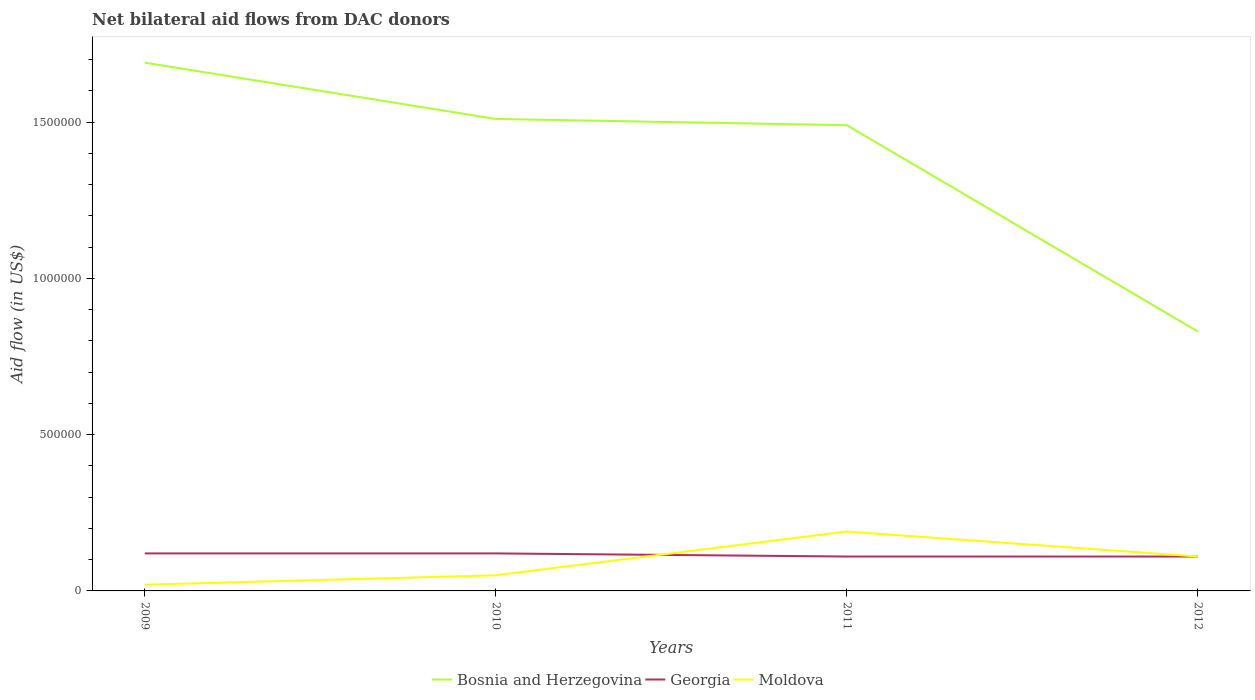How many different coloured lines are there?
Your answer should be very brief. 3. Across all years, what is the maximum net bilateral aid flow in Georgia?
Keep it short and to the point. 1.10e+05. What is the total net bilateral aid flow in Bosnia and Herzegovina in the graph?
Your response must be concise. 6.80e+05. Is the net bilateral aid flow in Bosnia and Herzegovina strictly greater than the net bilateral aid flow in Georgia over the years?
Your answer should be compact. No. What is the difference between two consecutive major ticks on the Y-axis?
Your response must be concise. 5.00e+05. Are the values on the major ticks of Y-axis written in scientific E-notation?
Your answer should be very brief. No. Does the graph contain any zero values?
Provide a succinct answer. No. Does the graph contain grids?
Your response must be concise. No. Where does the legend appear in the graph?
Your answer should be very brief. Bottom center. How many legend labels are there?
Ensure brevity in your answer.  3. What is the title of the graph?
Your answer should be compact. Net bilateral aid flows from DAC donors. Does "Equatorial Guinea" appear as one of the legend labels in the graph?
Provide a short and direct response. No. What is the label or title of the X-axis?
Your answer should be very brief. Years. What is the label or title of the Y-axis?
Your answer should be very brief. Aid flow (in US$). What is the Aid flow (in US$) of Bosnia and Herzegovina in 2009?
Offer a terse response. 1.69e+06. What is the Aid flow (in US$) of Moldova in 2009?
Your response must be concise. 2.00e+04. What is the Aid flow (in US$) of Bosnia and Herzegovina in 2010?
Your response must be concise. 1.51e+06. What is the Aid flow (in US$) in Moldova in 2010?
Provide a short and direct response. 5.00e+04. What is the Aid flow (in US$) in Bosnia and Herzegovina in 2011?
Your response must be concise. 1.49e+06. What is the Aid flow (in US$) in Georgia in 2011?
Make the answer very short. 1.10e+05. What is the Aid flow (in US$) in Bosnia and Herzegovina in 2012?
Keep it short and to the point. 8.30e+05. What is the Aid flow (in US$) in Georgia in 2012?
Ensure brevity in your answer.  1.10e+05. What is the Aid flow (in US$) in Moldova in 2012?
Your response must be concise. 1.10e+05. Across all years, what is the maximum Aid flow (in US$) in Bosnia and Herzegovina?
Offer a terse response. 1.69e+06. Across all years, what is the maximum Aid flow (in US$) in Moldova?
Your response must be concise. 1.90e+05. Across all years, what is the minimum Aid flow (in US$) of Bosnia and Herzegovina?
Keep it short and to the point. 8.30e+05. Across all years, what is the minimum Aid flow (in US$) of Moldova?
Make the answer very short. 2.00e+04. What is the total Aid flow (in US$) in Bosnia and Herzegovina in the graph?
Provide a succinct answer. 5.52e+06. What is the total Aid flow (in US$) of Georgia in the graph?
Provide a succinct answer. 4.60e+05. What is the total Aid flow (in US$) of Moldova in the graph?
Provide a succinct answer. 3.70e+05. What is the difference between the Aid flow (in US$) of Bosnia and Herzegovina in 2009 and that in 2010?
Your response must be concise. 1.80e+05. What is the difference between the Aid flow (in US$) in Georgia in 2009 and that in 2010?
Provide a succinct answer. 0. What is the difference between the Aid flow (in US$) in Moldova in 2009 and that in 2010?
Your answer should be very brief. -3.00e+04. What is the difference between the Aid flow (in US$) in Georgia in 2009 and that in 2011?
Your answer should be compact. 10000. What is the difference between the Aid flow (in US$) in Bosnia and Herzegovina in 2009 and that in 2012?
Your answer should be very brief. 8.60e+05. What is the difference between the Aid flow (in US$) of Bosnia and Herzegovina in 2010 and that in 2011?
Ensure brevity in your answer.  2.00e+04. What is the difference between the Aid flow (in US$) in Moldova in 2010 and that in 2011?
Offer a terse response. -1.40e+05. What is the difference between the Aid flow (in US$) of Bosnia and Herzegovina in 2010 and that in 2012?
Ensure brevity in your answer.  6.80e+05. What is the difference between the Aid flow (in US$) of Georgia in 2010 and that in 2012?
Provide a short and direct response. 10000. What is the difference between the Aid flow (in US$) in Moldova in 2010 and that in 2012?
Your answer should be compact. -6.00e+04. What is the difference between the Aid flow (in US$) in Bosnia and Herzegovina in 2011 and that in 2012?
Ensure brevity in your answer.  6.60e+05. What is the difference between the Aid flow (in US$) in Moldova in 2011 and that in 2012?
Give a very brief answer. 8.00e+04. What is the difference between the Aid flow (in US$) of Bosnia and Herzegovina in 2009 and the Aid flow (in US$) of Georgia in 2010?
Provide a succinct answer. 1.57e+06. What is the difference between the Aid flow (in US$) of Bosnia and Herzegovina in 2009 and the Aid flow (in US$) of Moldova in 2010?
Provide a short and direct response. 1.64e+06. What is the difference between the Aid flow (in US$) of Georgia in 2009 and the Aid flow (in US$) of Moldova in 2010?
Your answer should be very brief. 7.00e+04. What is the difference between the Aid flow (in US$) of Bosnia and Herzegovina in 2009 and the Aid flow (in US$) of Georgia in 2011?
Offer a terse response. 1.58e+06. What is the difference between the Aid flow (in US$) in Bosnia and Herzegovina in 2009 and the Aid flow (in US$) in Moldova in 2011?
Your answer should be compact. 1.50e+06. What is the difference between the Aid flow (in US$) in Georgia in 2009 and the Aid flow (in US$) in Moldova in 2011?
Make the answer very short. -7.00e+04. What is the difference between the Aid flow (in US$) in Bosnia and Herzegovina in 2009 and the Aid flow (in US$) in Georgia in 2012?
Give a very brief answer. 1.58e+06. What is the difference between the Aid flow (in US$) of Bosnia and Herzegovina in 2009 and the Aid flow (in US$) of Moldova in 2012?
Your answer should be compact. 1.58e+06. What is the difference between the Aid flow (in US$) in Bosnia and Herzegovina in 2010 and the Aid flow (in US$) in Georgia in 2011?
Your answer should be compact. 1.40e+06. What is the difference between the Aid flow (in US$) in Bosnia and Herzegovina in 2010 and the Aid flow (in US$) in Moldova in 2011?
Offer a very short reply. 1.32e+06. What is the difference between the Aid flow (in US$) of Bosnia and Herzegovina in 2010 and the Aid flow (in US$) of Georgia in 2012?
Make the answer very short. 1.40e+06. What is the difference between the Aid flow (in US$) of Bosnia and Herzegovina in 2010 and the Aid flow (in US$) of Moldova in 2012?
Your response must be concise. 1.40e+06. What is the difference between the Aid flow (in US$) in Georgia in 2010 and the Aid flow (in US$) in Moldova in 2012?
Keep it short and to the point. 10000. What is the difference between the Aid flow (in US$) in Bosnia and Herzegovina in 2011 and the Aid flow (in US$) in Georgia in 2012?
Give a very brief answer. 1.38e+06. What is the difference between the Aid flow (in US$) in Bosnia and Herzegovina in 2011 and the Aid flow (in US$) in Moldova in 2012?
Provide a short and direct response. 1.38e+06. What is the average Aid flow (in US$) of Bosnia and Herzegovina per year?
Offer a very short reply. 1.38e+06. What is the average Aid flow (in US$) in Georgia per year?
Your response must be concise. 1.15e+05. What is the average Aid flow (in US$) in Moldova per year?
Your response must be concise. 9.25e+04. In the year 2009, what is the difference between the Aid flow (in US$) in Bosnia and Herzegovina and Aid flow (in US$) in Georgia?
Give a very brief answer. 1.57e+06. In the year 2009, what is the difference between the Aid flow (in US$) of Bosnia and Herzegovina and Aid flow (in US$) of Moldova?
Provide a short and direct response. 1.67e+06. In the year 2009, what is the difference between the Aid flow (in US$) of Georgia and Aid flow (in US$) of Moldova?
Keep it short and to the point. 1.00e+05. In the year 2010, what is the difference between the Aid flow (in US$) in Bosnia and Herzegovina and Aid flow (in US$) in Georgia?
Give a very brief answer. 1.39e+06. In the year 2010, what is the difference between the Aid flow (in US$) of Bosnia and Herzegovina and Aid flow (in US$) of Moldova?
Give a very brief answer. 1.46e+06. In the year 2010, what is the difference between the Aid flow (in US$) in Georgia and Aid flow (in US$) in Moldova?
Provide a succinct answer. 7.00e+04. In the year 2011, what is the difference between the Aid flow (in US$) of Bosnia and Herzegovina and Aid flow (in US$) of Georgia?
Your answer should be compact. 1.38e+06. In the year 2011, what is the difference between the Aid flow (in US$) in Bosnia and Herzegovina and Aid flow (in US$) in Moldova?
Your response must be concise. 1.30e+06. In the year 2011, what is the difference between the Aid flow (in US$) of Georgia and Aid flow (in US$) of Moldova?
Make the answer very short. -8.00e+04. In the year 2012, what is the difference between the Aid flow (in US$) in Bosnia and Herzegovina and Aid flow (in US$) in Georgia?
Keep it short and to the point. 7.20e+05. In the year 2012, what is the difference between the Aid flow (in US$) of Bosnia and Herzegovina and Aid flow (in US$) of Moldova?
Make the answer very short. 7.20e+05. In the year 2012, what is the difference between the Aid flow (in US$) of Georgia and Aid flow (in US$) of Moldova?
Keep it short and to the point. 0. What is the ratio of the Aid flow (in US$) in Bosnia and Herzegovina in 2009 to that in 2010?
Give a very brief answer. 1.12. What is the ratio of the Aid flow (in US$) of Moldova in 2009 to that in 2010?
Offer a terse response. 0.4. What is the ratio of the Aid flow (in US$) in Bosnia and Herzegovina in 2009 to that in 2011?
Give a very brief answer. 1.13. What is the ratio of the Aid flow (in US$) in Georgia in 2009 to that in 2011?
Offer a very short reply. 1.09. What is the ratio of the Aid flow (in US$) of Moldova in 2009 to that in 2011?
Offer a very short reply. 0.11. What is the ratio of the Aid flow (in US$) of Bosnia and Herzegovina in 2009 to that in 2012?
Ensure brevity in your answer.  2.04. What is the ratio of the Aid flow (in US$) in Georgia in 2009 to that in 2012?
Your answer should be very brief. 1.09. What is the ratio of the Aid flow (in US$) of Moldova in 2009 to that in 2012?
Your response must be concise. 0.18. What is the ratio of the Aid flow (in US$) of Bosnia and Herzegovina in 2010 to that in 2011?
Ensure brevity in your answer.  1.01. What is the ratio of the Aid flow (in US$) in Moldova in 2010 to that in 2011?
Provide a succinct answer. 0.26. What is the ratio of the Aid flow (in US$) of Bosnia and Herzegovina in 2010 to that in 2012?
Provide a short and direct response. 1.82. What is the ratio of the Aid flow (in US$) in Moldova in 2010 to that in 2012?
Your answer should be compact. 0.45. What is the ratio of the Aid flow (in US$) in Bosnia and Herzegovina in 2011 to that in 2012?
Offer a terse response. 1.8. What is the ratio of the Aid flow (in US$) of Georgia in 2011 to that in 2012?
Offer a very short reply. 1. What is the ratio of the Aid flow (in US$) in Moldova in 2011 to that in 2012?
Your answer should be very brief. 1.73. What is the difference between the highest and the second highest Aid flow (in US$) in Bosnia and Herzegovina?
Provide a succinct answer. 1.80e+05. What is the difference between the highest and the second highest Aid flow (in US$) in Georgia?
Provide a succinct answer. 0. What is the difference between the highest and the lowest Aid flow (in US$) in Bosnia and Herzegovina?
Your answer should be very brief. 8.60e+05. What is the difference between the highest and the lowest Aid flow (in US$) of Georgia?
Your response must be concise. 10000. What is the difference between the highest and the lowest Aid flow (in US$) of Moldova?
Offer a terse response. 1.70e+05. 